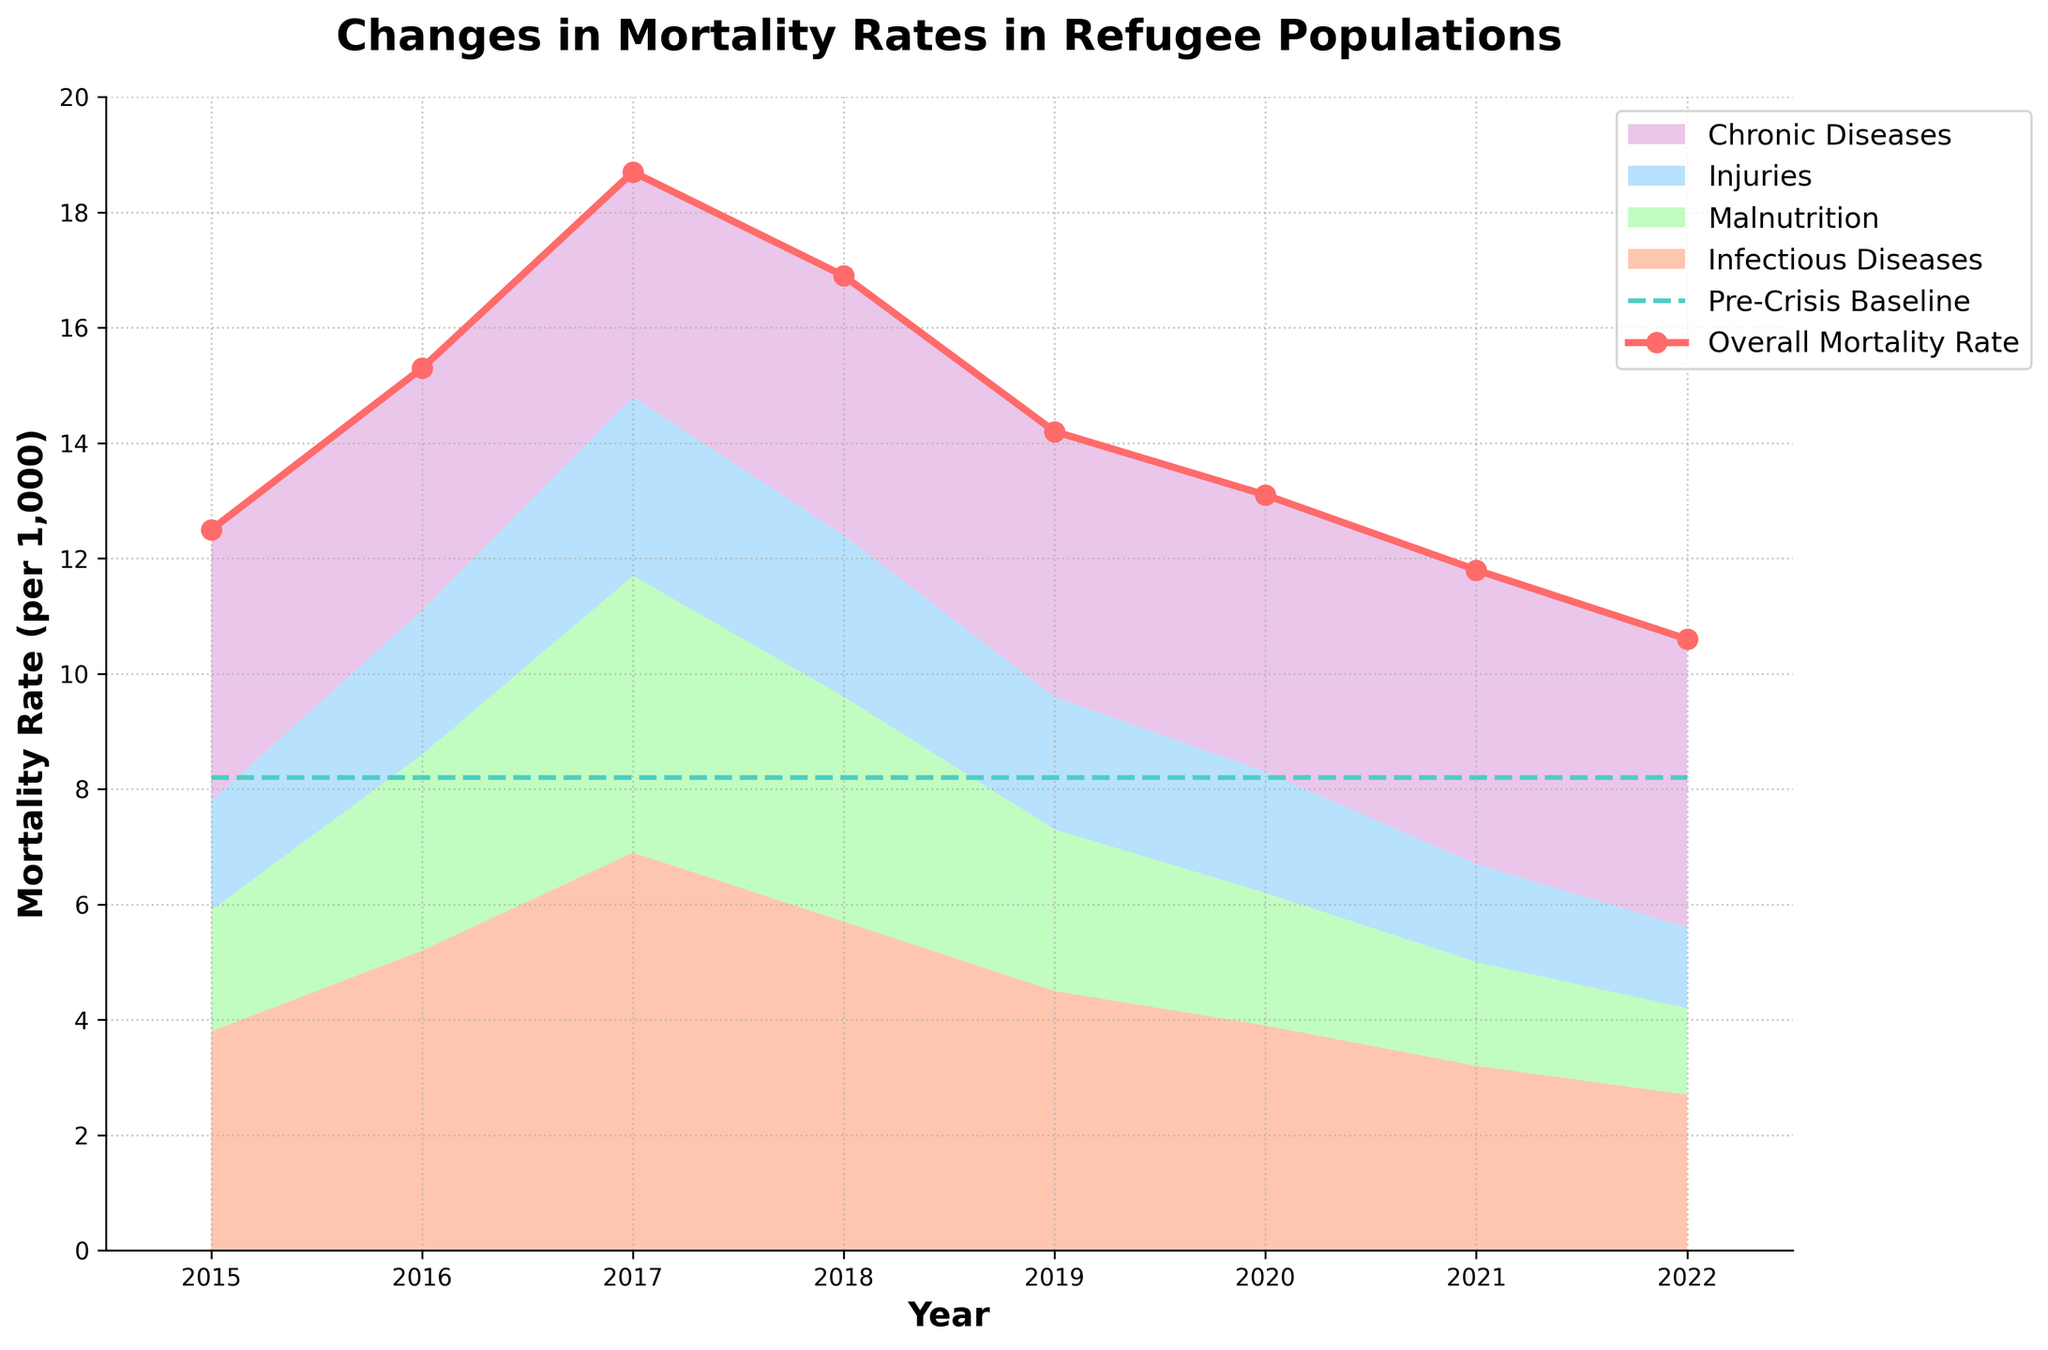Which year had the highest overall mortality rate? The highest point on the red line representing the overall mortality rate is in the year 2017.
Answer: 2017 How does the overall mortality rate in 2022 compare to the pre-crisis baseline? The overall mortality rate in 2022 is 10.6, which is higher than the pre-crisis baseline of 8.2 shown by the teal dashed line.
Answer: Higher Which cause of death had the highest rate in 2018, and what was the value? The stack plot section with the tallest height in 2018 is for Infectious Diseases, which is 5.7.
Answer: Infectious Diseases, 5.7 What is the overall trend for mortality rates from infectious diseases from 2015 to 2022? Describe the heights of the stack plot color representing infectious diseases. The heights decrease year by year from 3.8 in 2015 to 2.7 in 2022.
Answer: Decreasing What was the difference between the overall mortality rate and the pre-crisis baseline in 2016? The chart shows the overall mortality rate in 2016 is 15.3 and the pre-crisis baseline is 8.2. The difference is 15.3 - 8.2 = 7.1.
Answer: 7.1 Which cause of death had the smallest contribution to the overall mortality rate in 2020? Look at the stack plot for 2020 and identify the smallest section, which is for Injuries, contributing a value of 2.1.
Answer: Injuries, 2.1 How did the mortality rate due to chronic diseases change from 2017 to 2021? The chart for chronic diseases in 2017 shows a value of 3.9 and in 2021 it is 5.1. The change is 5.1 - 3.9 = 1.2.
Answer: Increased by 1.2 In which year did the mortality rate for Injuries peak, and what was the value? The pink area representing Injuries is highest in 2017 with a value of 3.1.
Answer: 2017, 3.1 Between which consecutive years did the overall mortality rate decrease the most? The red line shows that the largest drop is between 2017 (18.7) and 2018 (16.9). The decrease is 18.7 - 16.9 = 1.8.
Answer: 2017 to 2018, 1.8 